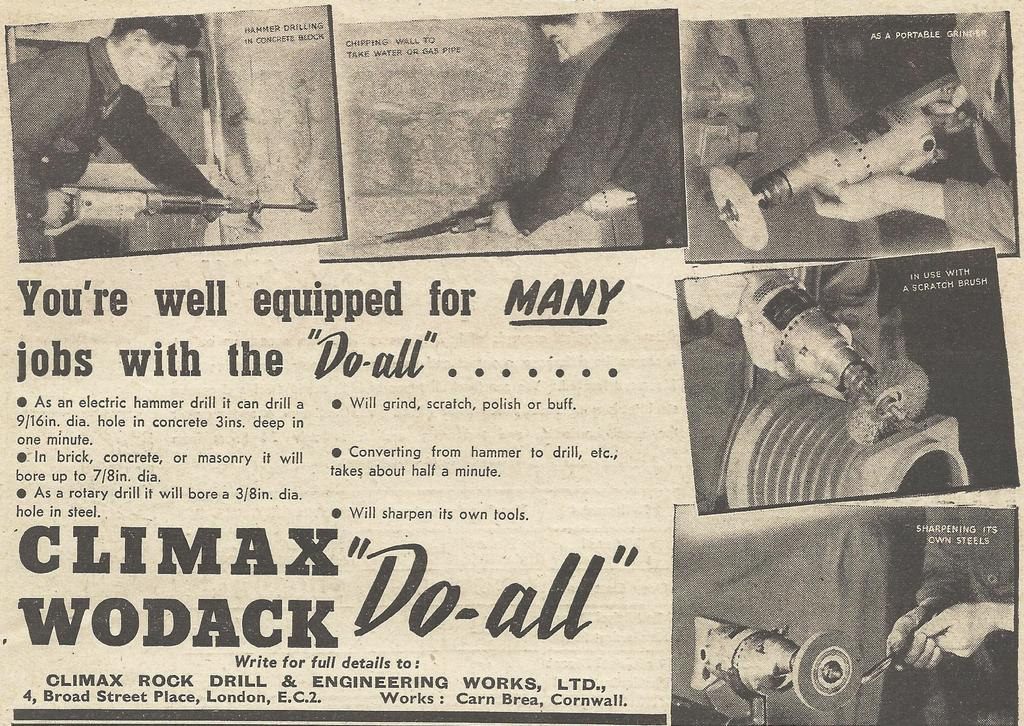What is present on the paper in the image? The paper contains pictures. What is the man holding in the image? The man is holding a driller in the image. Is there any text visible in the image? Yes, there is text in the image. Can you describe the flock of birds flying in the image? There are no birds or flock present in the image. How does the weather affect the man holding the driller in the image? The weather is not mentioned in the image, so it cannot be determined how it affects the man holding the driller. 